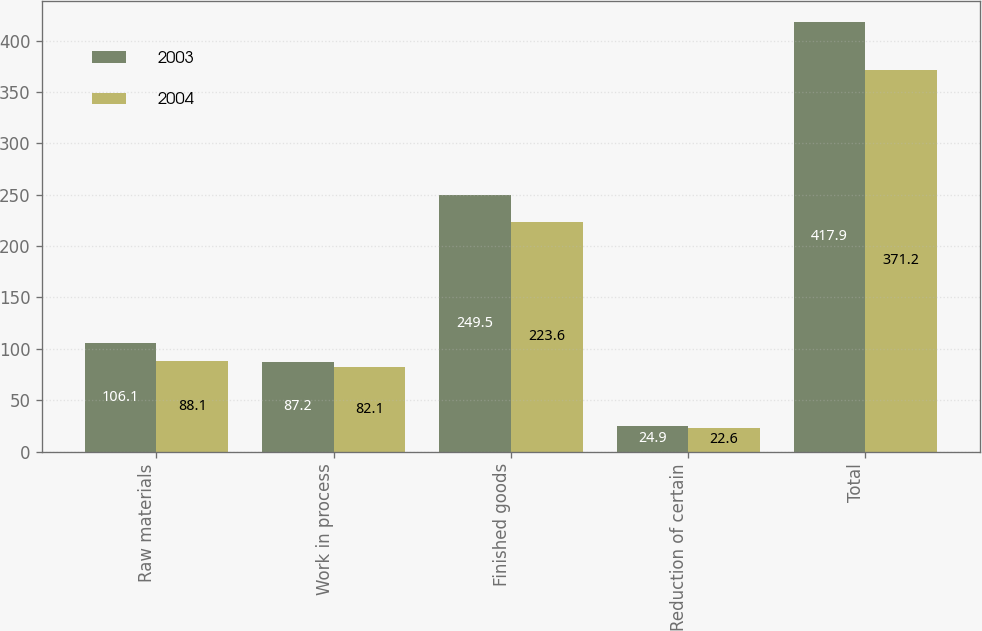<chart> <loc_0><loc_0><loc_500><loc_500><stacked_bar_chart><ecel><fcel>Raw materials<fcel>Work in process<fcel>Finished goods<fcel>Reduction of certain<fcel>Total<nl><fcel>2003<fcel>106.1<fcel>87.2<fcel>249.5<fcel>24.9<fcel>417.9<nl><fcel>2004<fcel>88.1<fcel>82.1<fcel>223.6<fcel>22.6<fcel>371.2<nl></chart> 